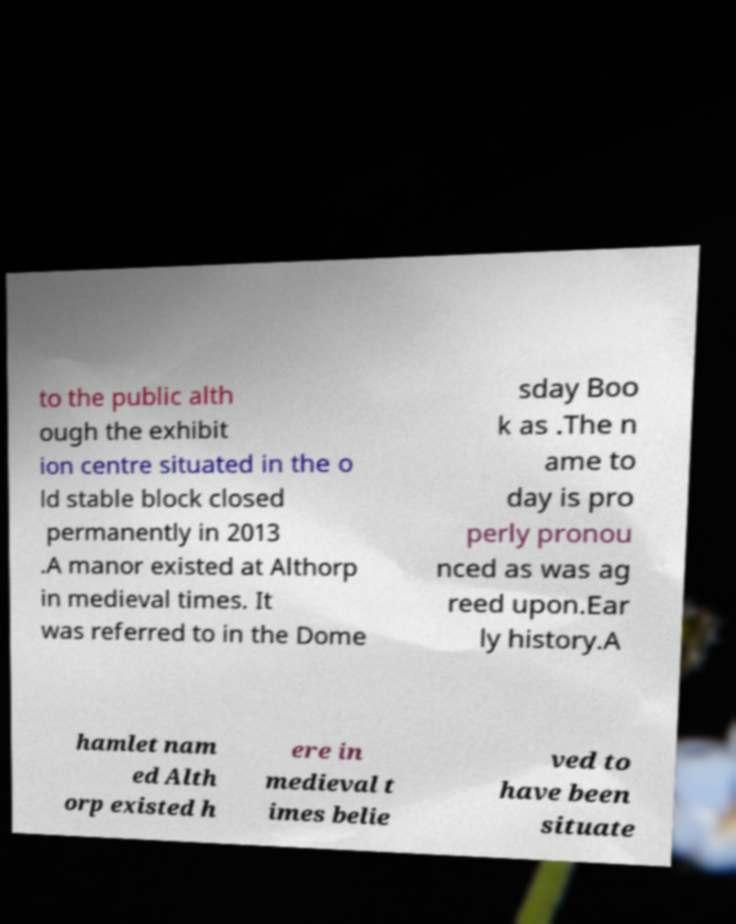Can you read and provide the text displayed in the image?This photo seems to have some interesting text. Can you extract and type it out for me? to the public alth ough the exhibit ion centre situated in the o ld stable block closed permanently in 2013 .A manor existed at Althorp in medieval times. It was referred to in the Dome sday Boo k as .The n ame to day is pro perly pronou nced as was ag reed upon.Ear ly history.A hamlet nam ed Alth orp existed h ere in medieval t imes belie ved to have been situate 